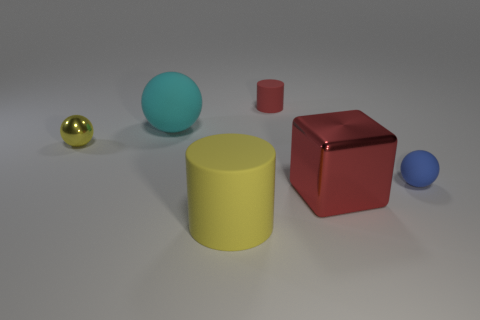How does the lighting in this scene affect the appearance of the objects? The lighting in the scene casts soft shadows and gives the objects a smooth, matte finish. It appears to be diffused, likely from an overhead source, which helps to highlight the colors and contours of the objects without creating harsh glares or overly dramatic shadows. This soft lighting enhances the overall calm and balanced aesthetic of the setting. 